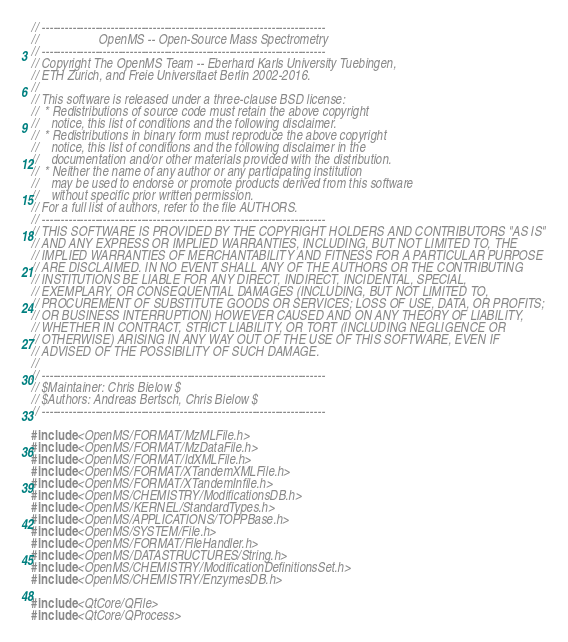<code> <loc_0><loc_0><loc_500><loc_500><_C++_>// --------------------------------------------------------------------------
//                   OpenMS -- Open-Source Mass Spectrometry
// --------------------------------------------------------------------------
// Copyright The OpenMS Team -- Eberhard Karls University Tuebingen,
// ETH Zurich, and Freie Universitaet Berlin 2002-2016.
//
// This software is released under a three-clause BSD license:
//  * Redistributions of source code must retain the above copyright
//    notice, this list of conditions and the following disclaimer.
//  * Redistributions in binary form must reproduce the above copyright
//    notice, this list of conditions and the following disclaimer in the
//    documentation and/or other materials provided with the distribution.
//  * Neither the name of any author or any participating institution
//    may be used to endorse or promote products derived from this software
//    without specific prior written permission.
// For a full list of authors, refer to the file AUTHORS.
// --------------------------------------------------------------------------
// THIS SOFTWARE IS PROVIDED BY THE COPYRIGHT HOLDERS AND CONTRIBUTORS "AS IS"
// AND ANY EXPRESS OR IMPLIED WARRANTIES, INCLUDING, BUT NOT LIMITED TO, THE
// IMPLIED WARRANTIES OF MERCHANTABILITY AND FITNESS FOR A PARTICULAR PURPOSE
// ARE DISCLAIMED. IN NO EVENT SHALL ANY OF THE AUTHORS OR THE CONTRIBUTING
// INSTITUTIONS BE LIABLE FOR ANY DIRECT, INDIRECT, INCIDENTAL, SPECIAL,
// EXEMPLARY, OR CONSEQUENTIAL DAMAGES (INCLUDING, BUT NOT LIMITED TO,
// PROCUREMENT OF SUBSTITUTE GOODS OR SERVICES; LOSS OF USE, DATA, OR PROFITS;
// OR BUSINESS INTERRUPTION) HOWEVER CAUSED AND ON ANY THEORY OF LIABILITY,
// WHETHER IN CONTRACT, STRICT LIABILITY, OR TORT (INCLUDING NEGLIGENCE OR
// OTHERWISE) ARISING IN ANY WAY OUT OF THE USE OF THIS SOFTWARE, EVEN IF
// ADVISED OF THE POSSIBILITY OF SUCH DAMAGE.
//
// --------------------------------------------------------------------------
// $Maintainer: Chris Bielow $
// $Authors: Andreas Bertsch, Chris Bielow $
// --------------------------------------------------------------------------

#include <OpenMS/FORMAT/MzMLFile.h>
#include <OpenMS/FORMAT/MzDataFile.h>
#include <OpenMS/FORMAT/IdXMLFile.h>
#include <OpenMS/FORMAT/XTandemXMLFile.h>
#include <OpenMS/FORMAT/XTandemInfile.h>
#include <OpenMS/CHEMISTRY/ModificationsDB.h>
#include <OpenMS/KERNEL/StandardTypes.h>
#include <OpenMS/APPLICATIONS/TOPPBase.h>
#include <OpenMS/SYSTEM/File.h>
#include <OpenMS/FORMAT/FileHandler.h>
#include <OpenMS/DATASTRUCTURES/String.h>
#include <OpenMS/CHEMISTRY/ModificationDefinitionsSet.h>
#include <OpenMS/CHEMISTRY/EnzymesDB.h>

#include <QtCore/QFile>
#include <QtCore/QProcess></code> 